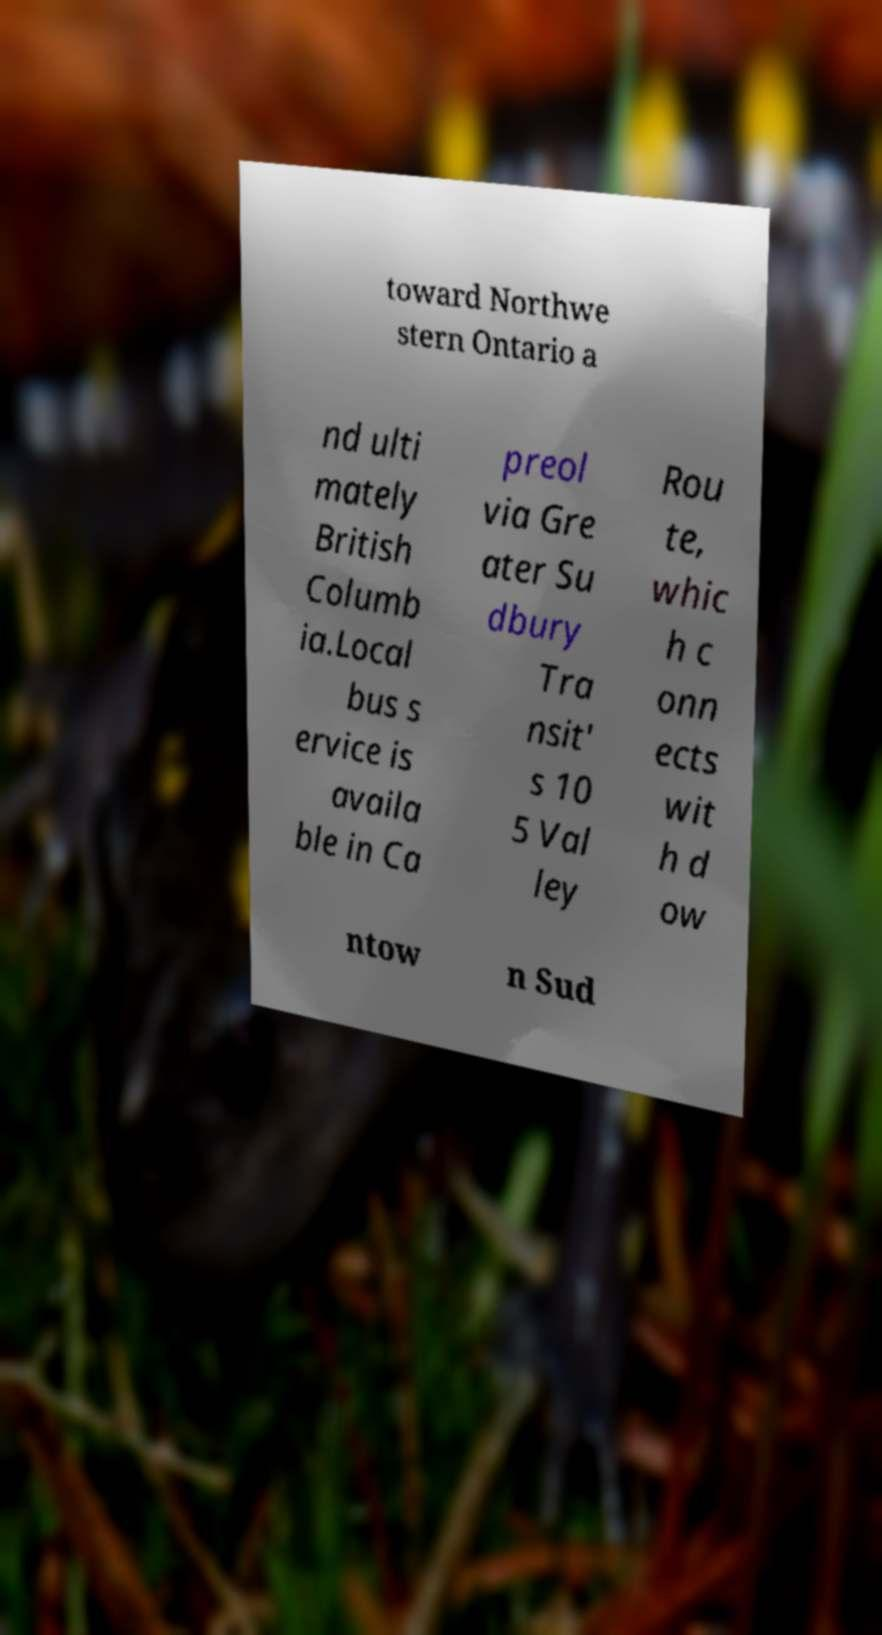I need the written content from this picture converted into text. Can you do that? toward Northwe stern Ontario a nd ulti mately British Columb ia.Local bus s ervice is availa ble in Ca preol via Gre ater Su dbury Tra nsit' s 10 5 Val ley Rou te, whic h c onn ects wit h d ow ntow n Sud 